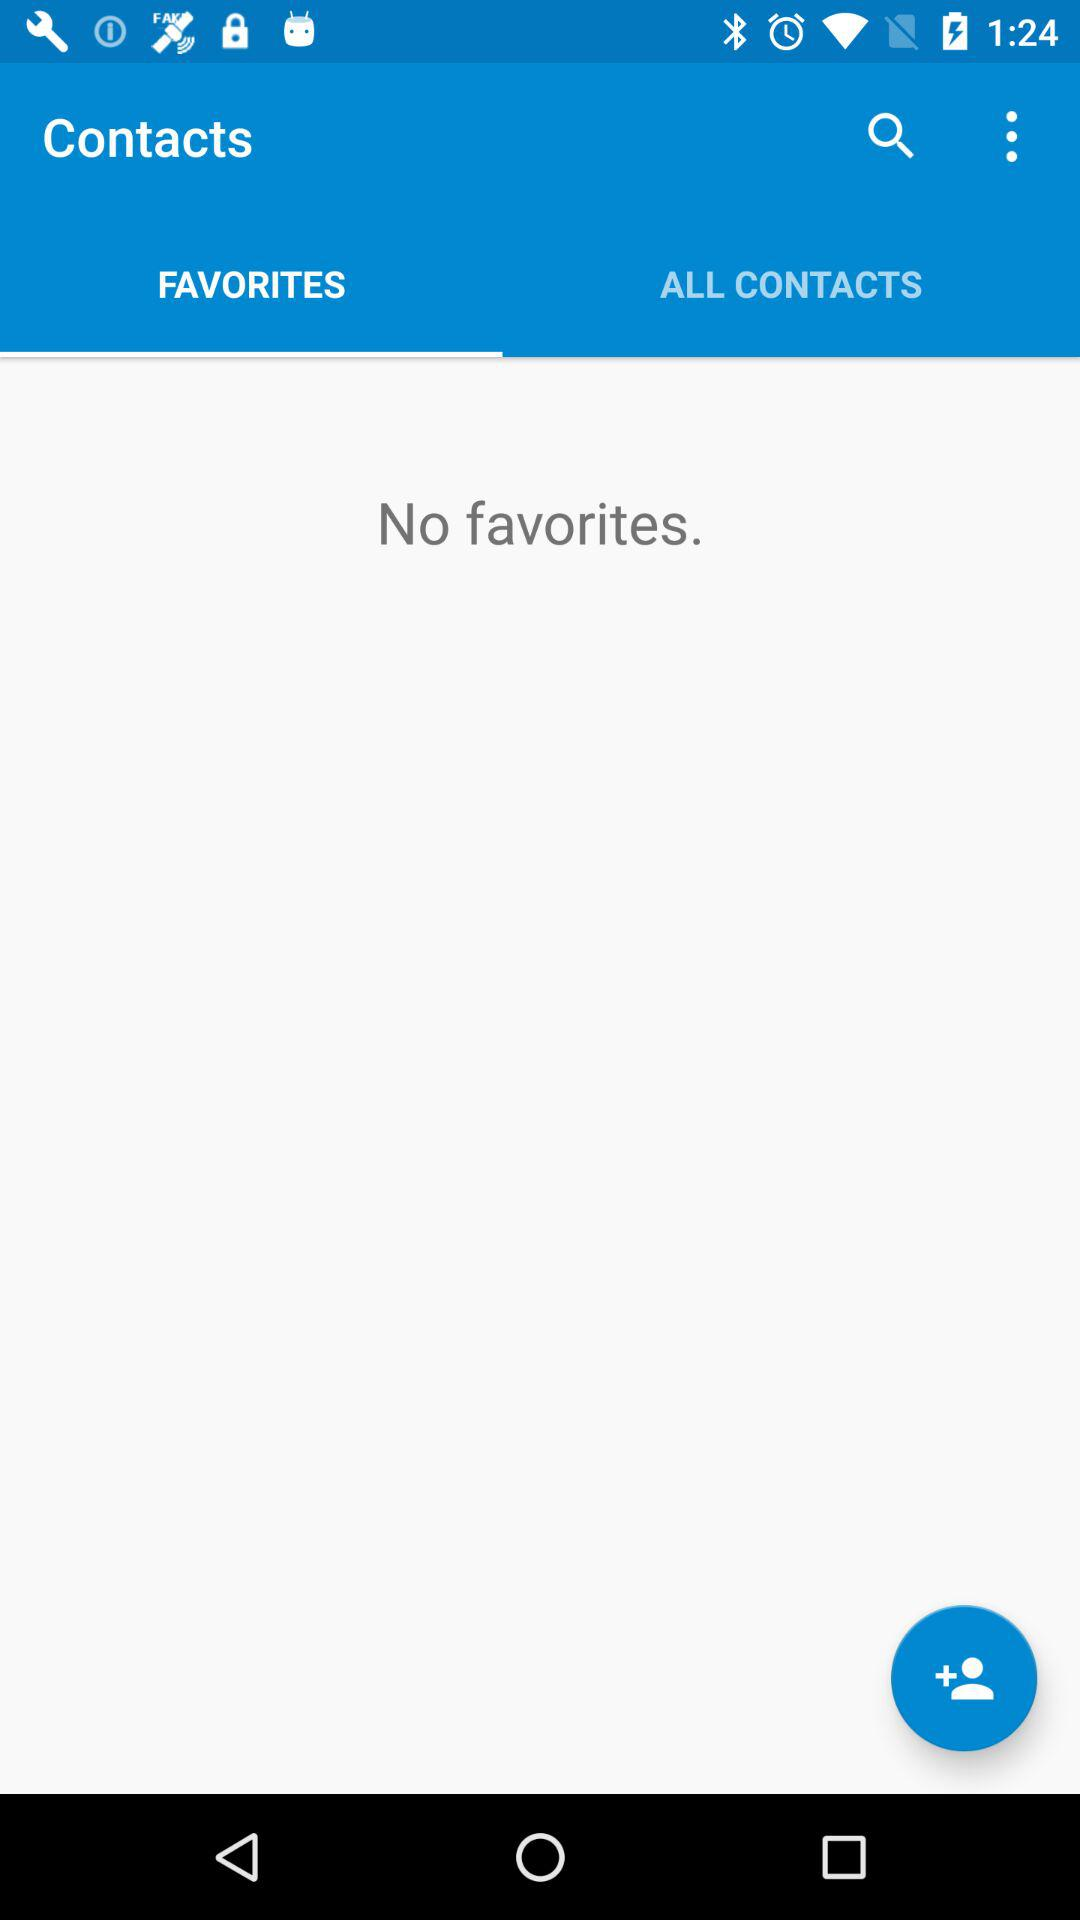Which tab is selected? The selected tab is "FAVORITES". 